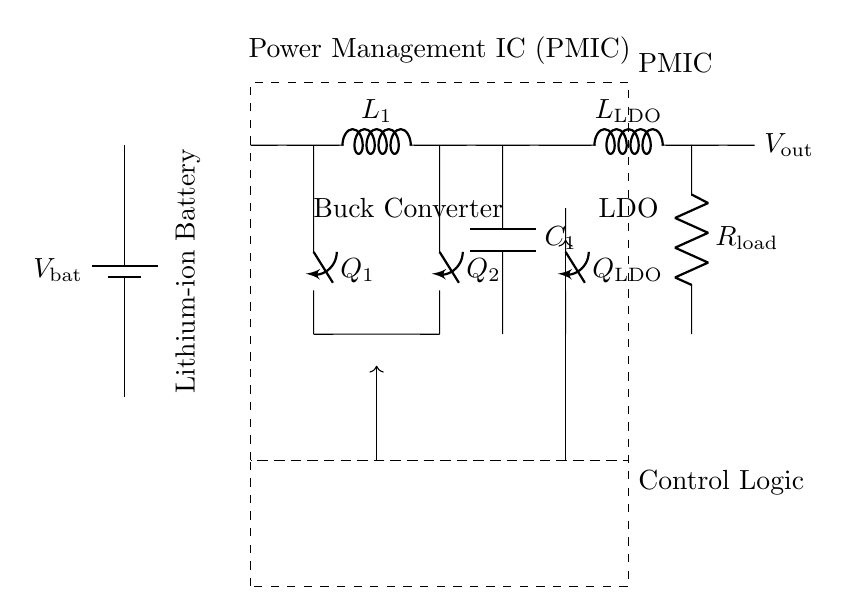What is the input voltage of the PMIC? The input voltage is the voltage provided by the battery, denoted as V_bat in the diagram.
Answer: V_bat What type of converter is used in this circuit? The circuit includes a buck converter, which is indicated in the diagram as part of the PMIC section for efficient voltage regulation.
Answer: Buck converter How many switches are present in the circuit? The circuit has three switches, specifically two for the buck converter (Q_1, Q_2) and one for the LDO (Q_LDO).
Answer: Three switches What component is used to smooth the output voltage? The smoothing component is a capacitor, labeled as C_1 in the circuit, which helps reduce voltage fluctuations at the output.
Answer: C_1 Why is a buck converter used in this PMIC? The buck converter is employed to step down voltage efficiently, which is necessary for optimizing battery usage and delivering the required output voltage at lower levels than the battery voltage.
Answer: To step down voltage efficiently What is the purpose of the control logic in the circuit? The control logic regulates the operation of the buck converter and the LDO by controlling the switching elements (Q_1, Q_2, Q_LDO) to ensure optimal performance.
Answer: Regulation of operation 